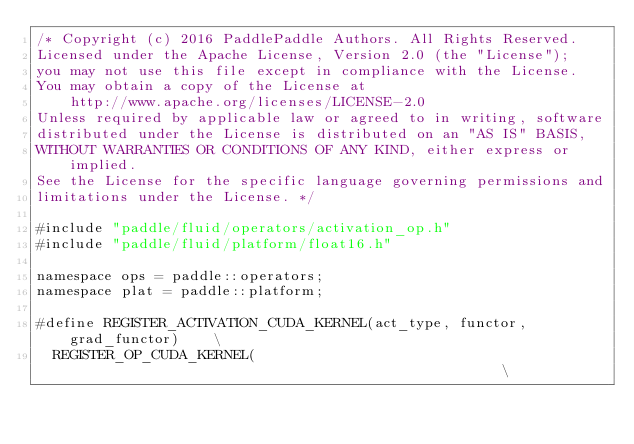<code> <loc_0><loc_0><loc_500><loc_500><_Cuda_>/* Copyright (c) 2016 PaddlePaddle Authors. All Rights Reserved.
Licensed under the Apache License, Version 2.0 (the "License");
you may not use this file except in compliance with the License.
You may obtain a copy of the License at
    http://www.apache.org/licenses/LICENSE-2.0
Unless required by applicable law or agreed to in writing, software
distributed under the License is distributed on an "AS IS" BASIS,
WITHOUT WARRANTIES OR CONDITIONS OF ANY KIND, either express or implied.
See the License for the specific language governing permissions and
limitations under the License. */

#include "paddle/fluid/operators/activation_op.h"
#include "paddle/fluid/platform/float16.h"

namespace ops = paddle::operators;
namespace plat = paddle::platform;

#define REGISTER_ACTIVATION_CUDA_KERNEL(act_type, functor, grad_functor)    \
  REGISTER_OP_CUDA_KERNEL(                                                  \</code> 